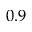<formula> <loc_0><loc_0><loc_500><loc_500>0 . 9</formula> 